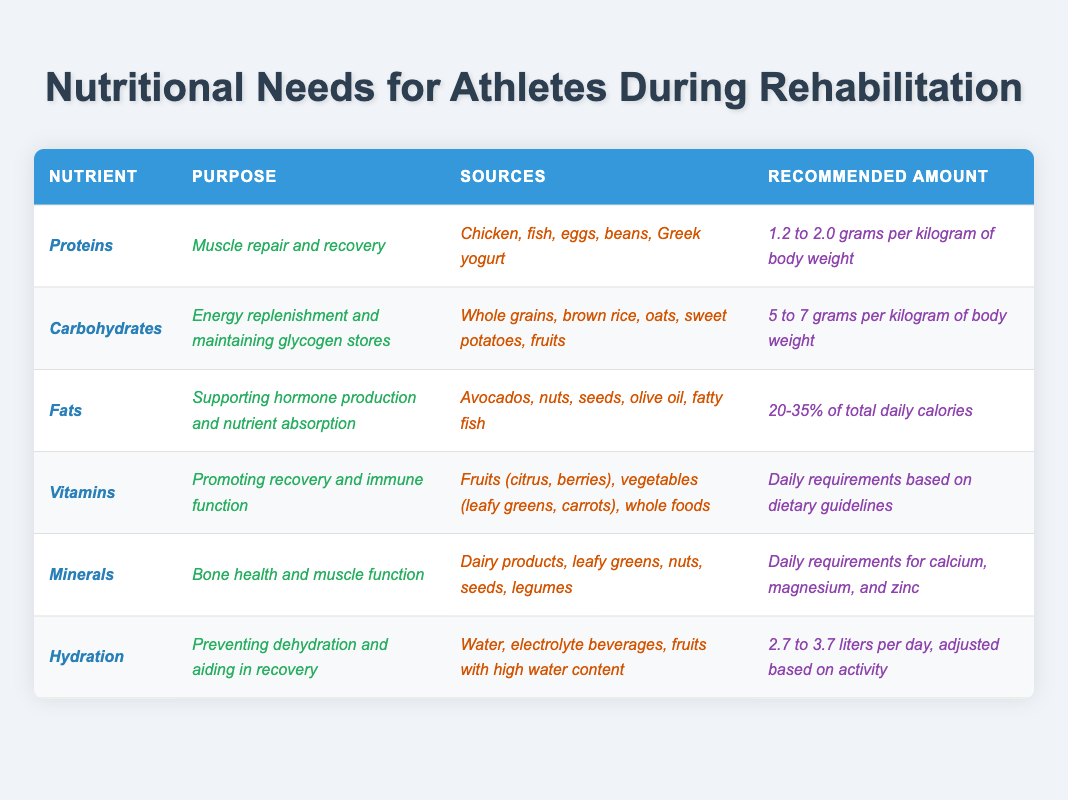What is the recommended amount of protein for an athlete during rehabilitation? The table specifies that the recommended amount of protein is between 1.2 to 2.0 grams per kilogram of body weight.
Answer: 1.2 to 2.0 grams per kilogram Which nutrient is essential for muscle repair and recovery? The table indicates that proteins are crucial for muscle repair and recovery.
Answer: Proteins What are the main sources of carbohydrates listed in the table? The table lists whole grains, brown rice, oats, sweet potatoes, and fruits as sources of carbohydrates.
Answer: Whole grains, brown rice, oats, sweet potatoes, fruits Is hydration important for recovery? The table states that hydration is important for preventing dehydration and aiding recovery, indicating that this statement is true.
Answer: Yes What percentage of daily calories should come from fats? According to the table, fats should constitute 20-35% of total daily calories.
Answer: 20-35% What is the purpose of vitamins as described in the table? The table mentions that the purpose of vitamins is to promote recovery and support immune function.
Answer: Promote recovery and support immune function If an athlete weighs 70 kg, what is the minimum recommended amount of carbohydrates they should consume? The table recommends 5 to 7 grams of carbohydrates per kilogram of body weight. For a 70 kg athlete, the minimum amount is 70 kg * 5 g/kg = 350 grams.
Answer: 350 grams How many liters of hydration should an athlete aim for daily? The table indicates that an athlete should aim for 2.7 to 3.7 liters of hydration daily, depending on activity.
Answer: 2.7 to 3.7 liters Which nutrient supports hormone production and nutrient absorption? The table states that fats are the nutrients that support hormone production and nutrient absorption.
Answer: Fats Calculate the average recommended amount of protein and carbohydrates for an athlete. The average protein amount is (1.2 + 2.0) / 2 = 1.6 grams per kilogram; the average carbohydrate amount is (5 + 7) / 2 = 6 grams per kilogram. Thus, the average for both is 1.6 grams for protein and 6 grams for carbohydrates.
Answer: 1.6 grams (protein), 6 grams (carbohydrates) 